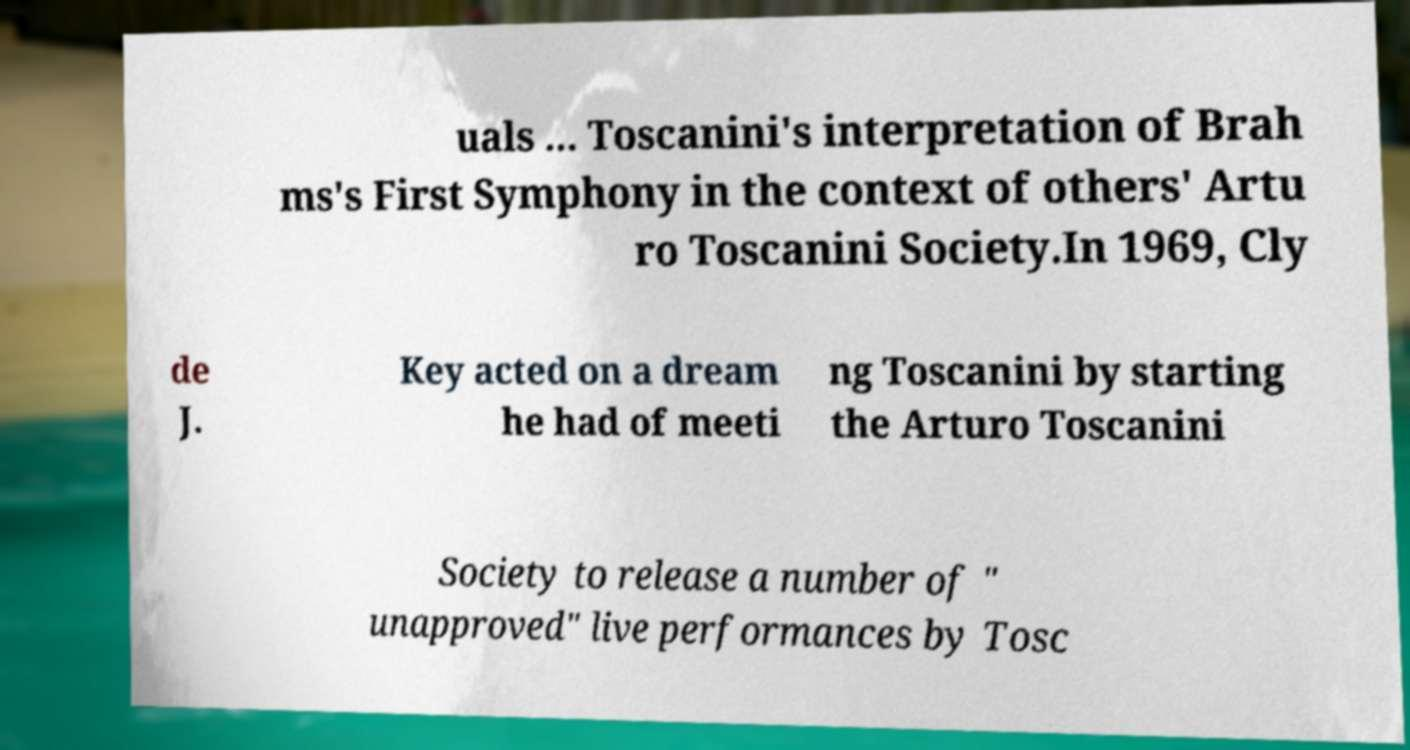Could you extract and type out the text from this image? uals ... Toscanini's interpretation of Brah ms's First Symphony in the context of others' Artu ro Toscanini Society.In 1969, Cly de J. Key acted on a dream he had of meeti ng Toscanini by starting the Arturo Toscanini Society to release a number of " unapproved" live performances by Tosc 